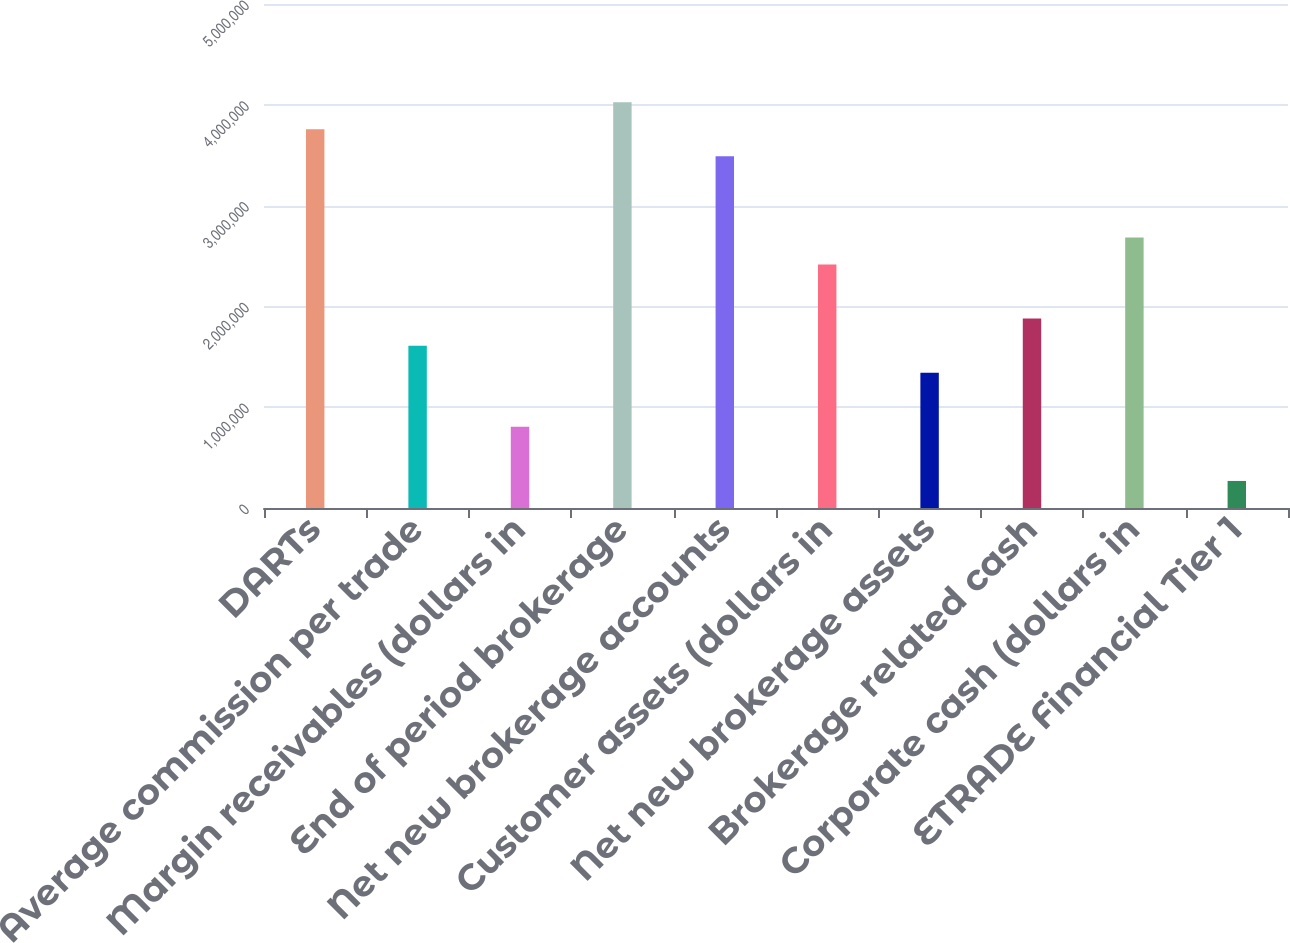<chart> <loc_0><loc_0><loc_500><loc_500><bar_chart><fcel>DARTs<fcel>Average commission per trade<fcel>Margin receivables (dollars in<fcel>End of period brokerage<fcel>Net new brokerage accounts<fcel>Customer assets (dollars in<fcel>Net new brokerage assets<fcel>Brokerage related cash<fcel>Corporate cash (dollars in<fcel>ETRADE Financial Tier 1<nl><fcel>3.75803e+06<fcel>1.61059e+06<fcel>805295<fcel>4.02647e+06<fcel>3.4896e+06<fcel>2.41588e+06<fcel>1.34216e+06<fcel>1.87902e+06<fcel>2.68431e+06<fcel>268434<nl></chart> 